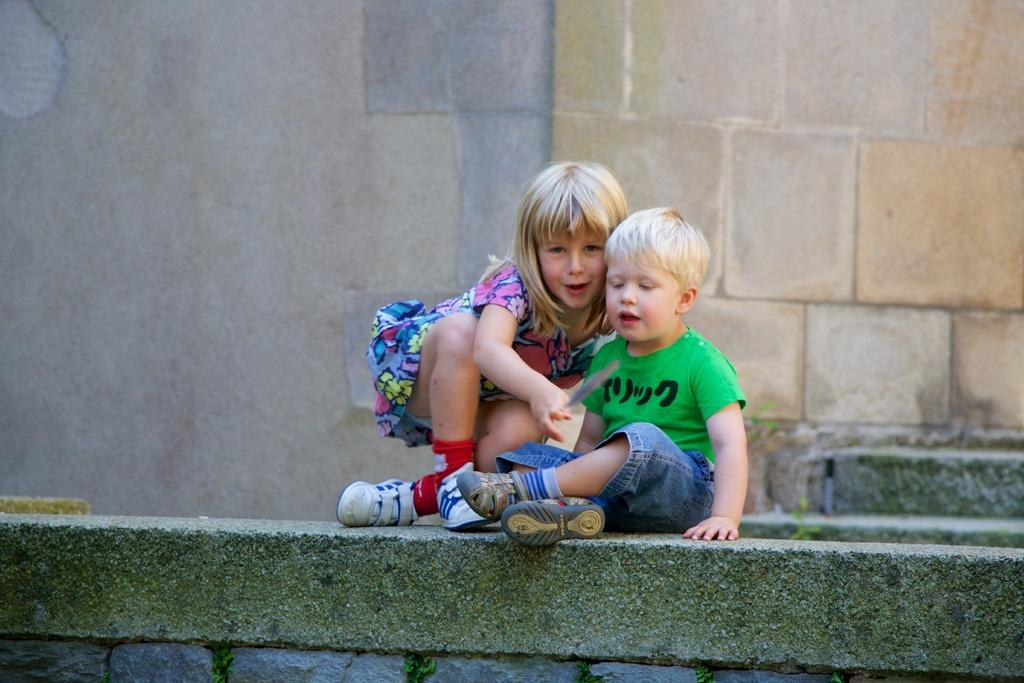Who are the people in the image? There is a girl and a boy in the image. What are they wearing on their feet? Both the girl and the boy are wearing shoes. Where are they sitting? They are sitting on a platform. What can be seen in the background of the image? There is a wall in the background of the image. What type of rings are the girl and the boy wearing in the image? There are no rings visible on the girl or the boy in the image. 